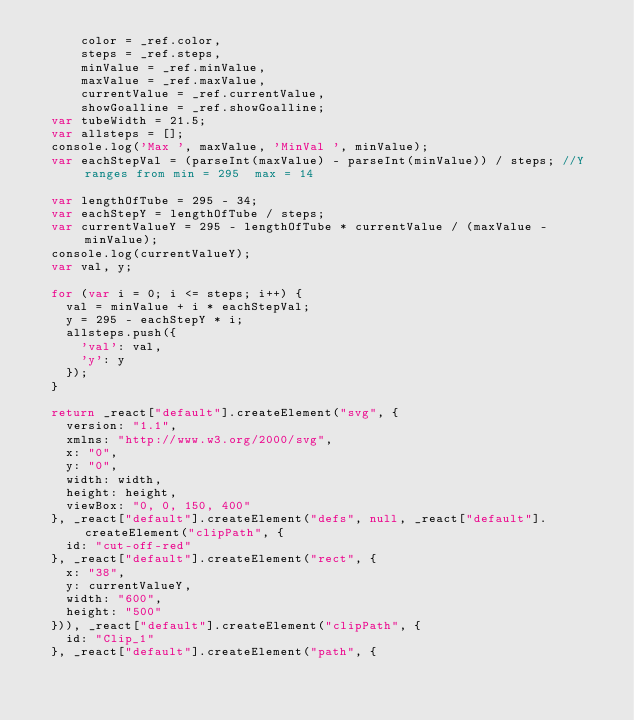Convert code to text. <code><loc_0><loc_0><loc_500><loc_500><_JavaScript_>      color = _ref.color,
      steps = _ref.steps,
      minValue = _ref.minValue,
      maxValue = _ref.maxValue,
      currentValue = _ref.currentValue,
      showGoalline = _ref.showGoalline;
  var tubeWidth = 21.5;
  var allsteps = [];
  console.log('Max ', maxValue, 'MinVal ', minValue);
  var eachStepVal = (parseInt(maxValue) - parseInt(minValue)) / steps; //Y ranges from min = 295  max = 14  

  var lengthOfTube = 295 - 34;
  var eachStepY = lengthOfTube / steps;
  var currentValueY = 295 - lengthOfTube * currentValue / (maxValue - minValue);
  console.log(currentValueY);
  var val, y;

  for (var i = 0; i <= steps; i++) {
    val = minValue + i * eachStepVal;
    y = 295 - eachStepY * i;
    allsteps.push({
      'val': val,
      'y': y
    });
  }

  return _react["default"].createElement("svg", {
    version: "1.1",
    xmlns: "http://www.w3.org/2000/svg",
    x: "0",
    y: "0",
    width: width,
    height: height,
    viewBox: "0, 0, 150, 400"
  }, _react["default"].createElement("defs", null, _react["default"].createElement("clipPath", {
    id: "cut-off-red"
  }, _react["default"].createElement("rect", {
    x: "38",
    y: currentValueY,
    width: "600",
    height: "500"
  })), _react["default"].createElement("clipPath", {
    id: "Clip_1"
  }, _react["default"].createElement("path", {</code> 